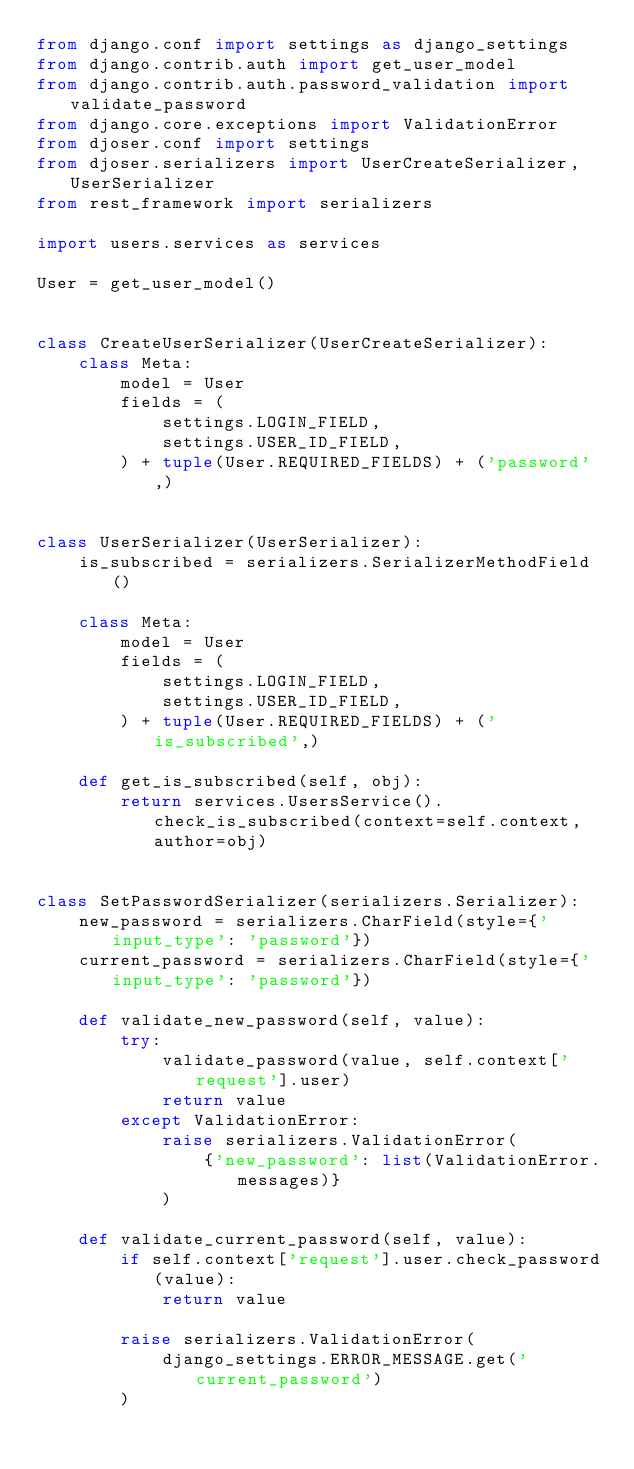Convert code to text. <code><loc_0><loc_0><loc_500><loc_500><_Python_>from django.conf import settings as django_settings
from django.contrib.auth import get_user_model
from django.contrib.auth.password_validation import validate_password
from django.core.exceptions import ValidationError
from djoser.conf import settings
from djoser.serializers import UserCreateSerializer, UserSerializer
from rest_framework import serializers

import users.services as services

User = get_user_model()


class CreateUserSerializer(UserCreateSerializer):
    class Meta:
        model = User
        fields = (
            settings.LOGIN_FIELD,
            settings.USER_ID_FIELD,
        ) + tuple(User.REQUIRED_FIELDS) + ('password',)


class UserSerializer(UserSerializer):
    is_subscribed = serializers.SerializerMethodField()

    class Meta:
        model = User
        fields = (
            settings.LOGIN_FIELD,
            settings.USER_ID_FIELD,
        ) + tuple(User.REQUIRED_FIELDS) + ('is_subscribed',)

    def get_is_subscribed(self, obj):
        return services.UsersService().check_is_subscribed(context=self.context, author=obj)


class SetPasswordSerializer(serializers.Serializer):
    new_password = serializers.CharField(style={'input_type': 'password'})
    current_password = serializers.CharField(style={'input_type': 'password'})

    def validate_new_password(self, value):
        try:
            validate_password(value, self.context['request'].user)
            return value
        except ValidationError:
            raise serializers.ValidationError(
                {'new_password': list(ValidationError.messages)}
            )

    def validate_current_password(self, value):
        if self.context['request'].user.check_password(value):
            return value

        raise serializers.ValidationError(
            django_settings.ERROR_MESSAGE.get('current_password')
        )
</code> 